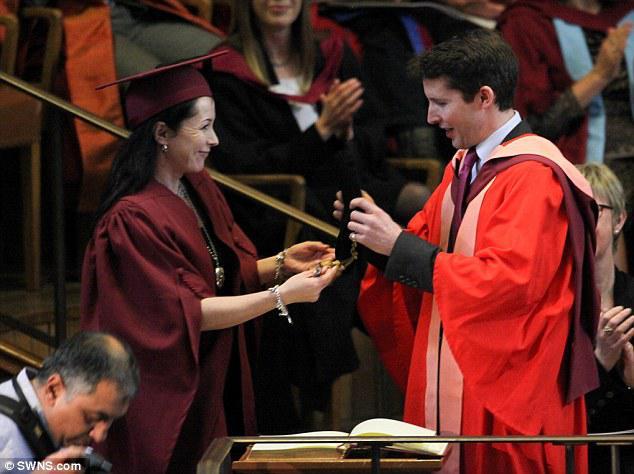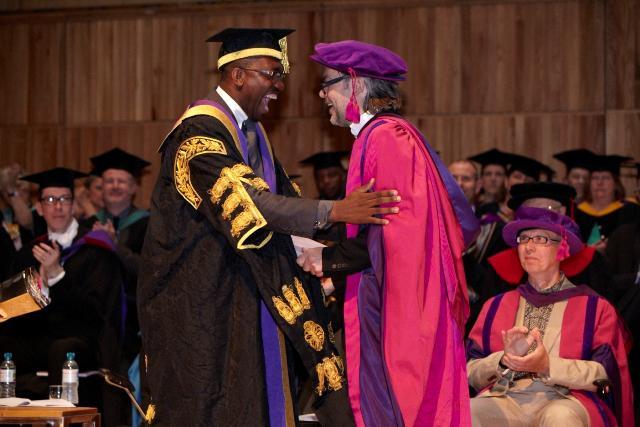The first image is the image on the left, the second image is the image on the right. For the images shown, is this caption "The right image contains no more than two people wearing graduation gowns." true? Answer yes or no. No. The first image is the image on the left, the second image is the image on the right. Evaluate the accuracy of this statement regarding the images: "An image shows a woman in a burgundy graduation robe next to a man in a bright red robe with pink and burgundy sashes.". Is it true? Answer yes or no. Yes. 